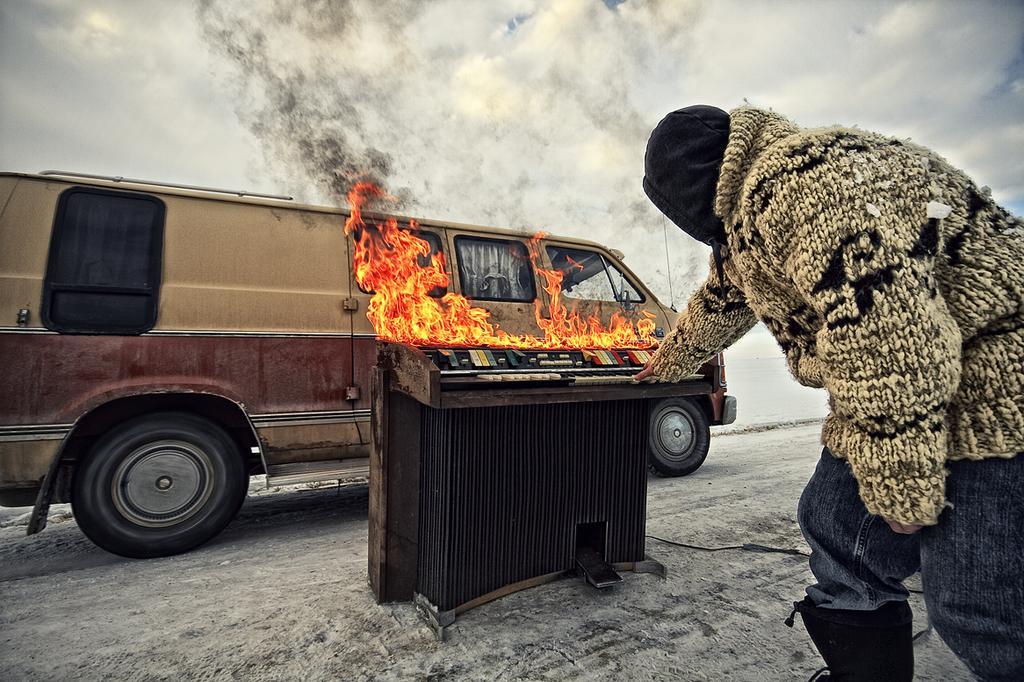Can you describe this image briefly? In this image, we can see a van, there is an object burning, on the right side there is a person standing, at the top we can see the sky. 